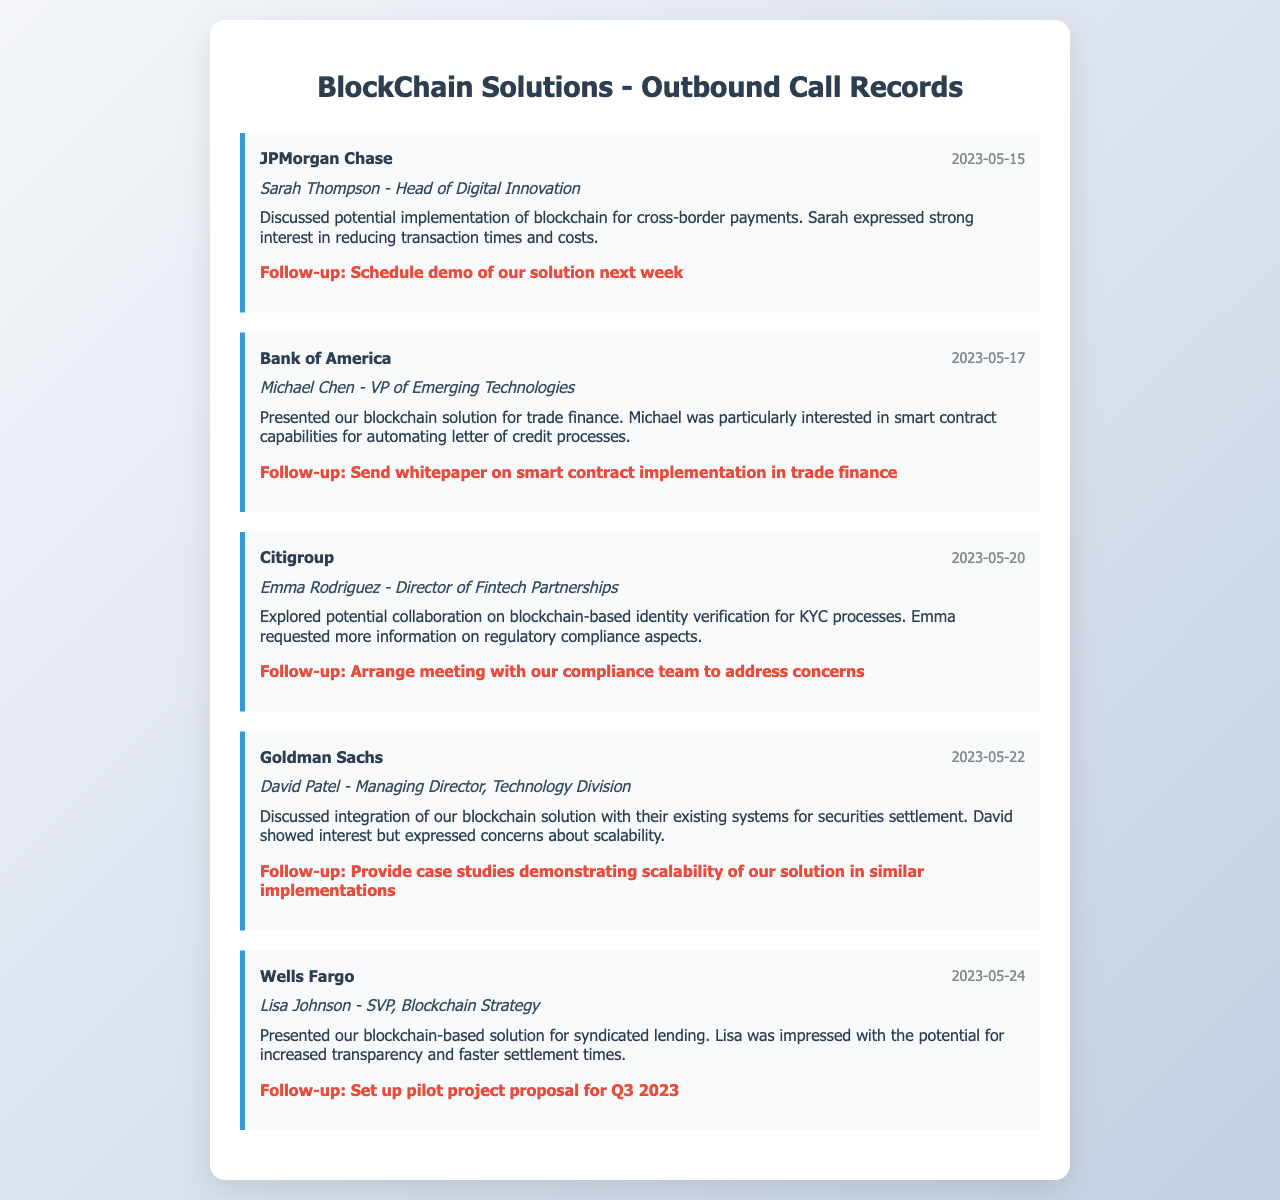What was the date of the call with JPMorgan Chase? The date of the call is mentioned in the document under the call record for JPMorgan Chase.
Answer: 2023-05-15 Who was the contact person at Bank of America? The contact person is listed in the document for the Bank of America call record.
Answer: Michael Chen What was the main topic discussed with Citigroup? The document summarizes discussions with each institution, specifically under the call record with Citigroup.
Answer: Blockchain-based identity verification What follow-up action was decided for Goldman Sachs? The follow-up action is explicitly stated in the document under the call record for Goldman Sachs.
Answer: Provide case studies demonstrating scalability Which financial institution expressed strong interest in reducing transaction times? Interest intentions for each institution are summarized in the respective call record, particularly with JPMorgan Chase.
Answer: JPMorgan Chase How many institutions were called in total? By counting the call records provided in the document, the total number of institutions can be determined.
Answer: 5 What was Lisa Johnson's role at Wells Fargo? The document specifies the title of the contact person under the Wells Fargo call record.
Answer: SVP, Blockchain Strategy What was the follow-up action for the Bank of America call? The follow-up action is clearly mentioned under the call record for Bank of America.
Answer: Send whitepaper on smart contract implementation in trade finance What is the purpose of the call records in this document? The overarching purpose of the call records can be inferred from the context in the document.
Answer: Outbound marketing calls to financial institutions 